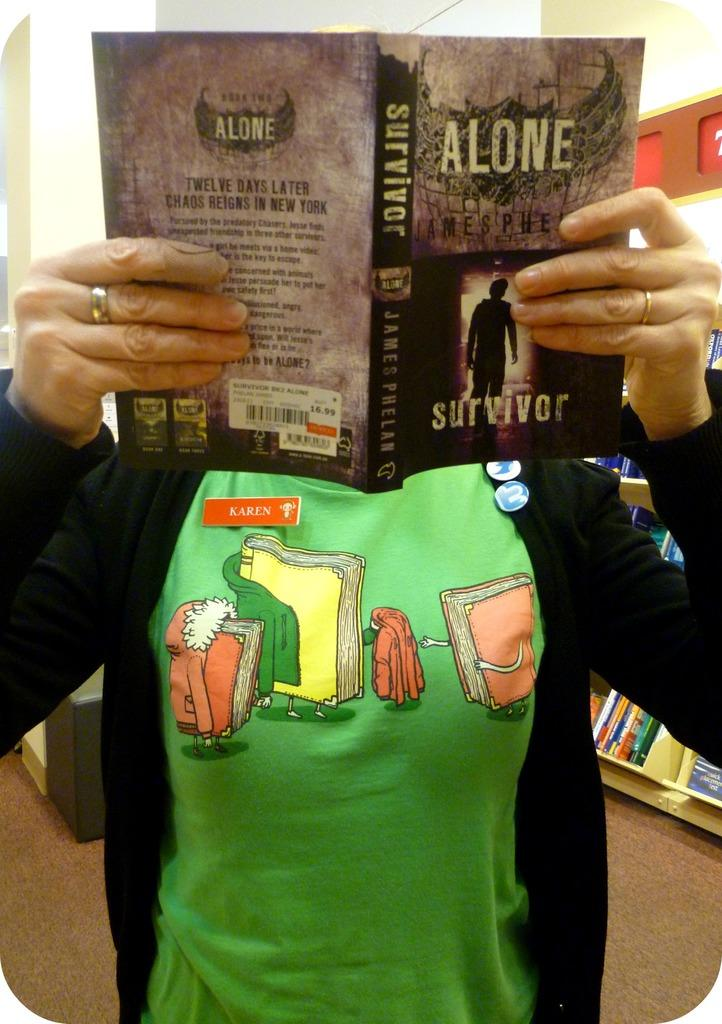<image>
Give a short and clear explanation of the subsequent image. A woman holding a book in front of her face titled Alone. 